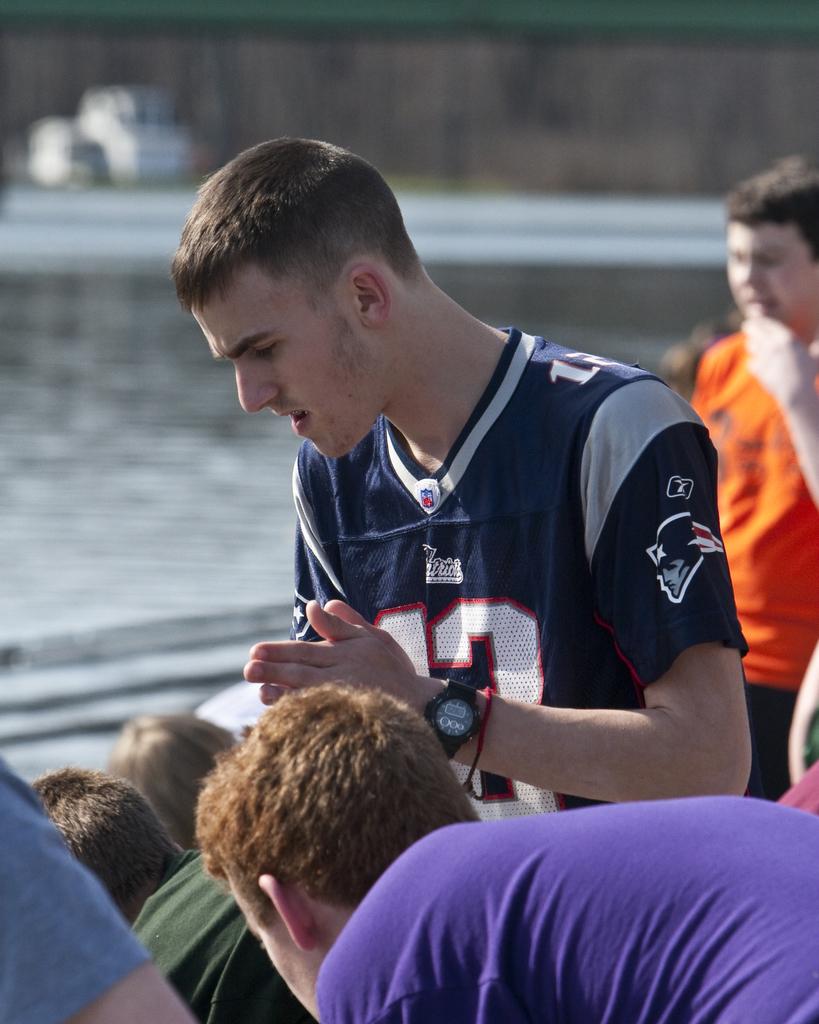What teams jersey is this boy wearing?
Keep it short and to the point. Patriots. Is that the number thirteen on the front of his shirt?
Provide a succinct answer. Yes. 